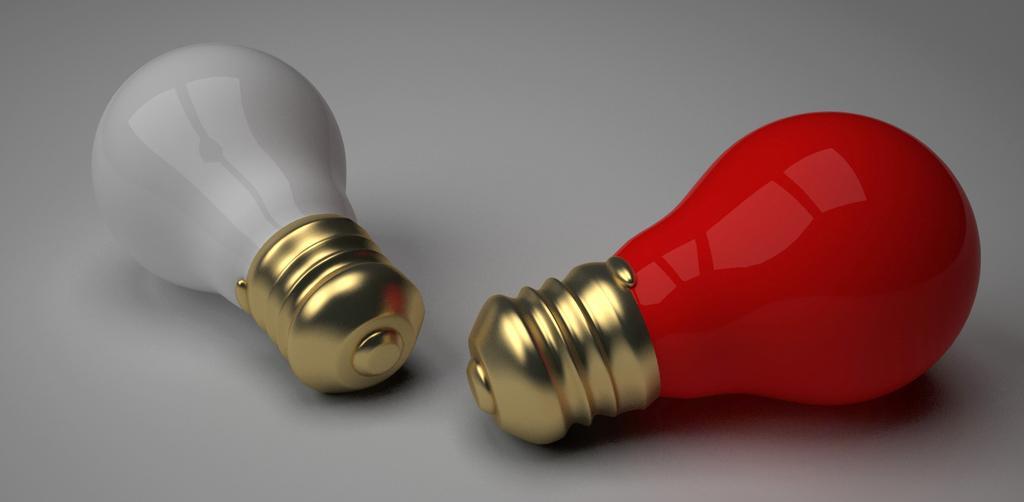Please provide a concise description of this image. The picture consists of white and red bulbs on a white surface. 